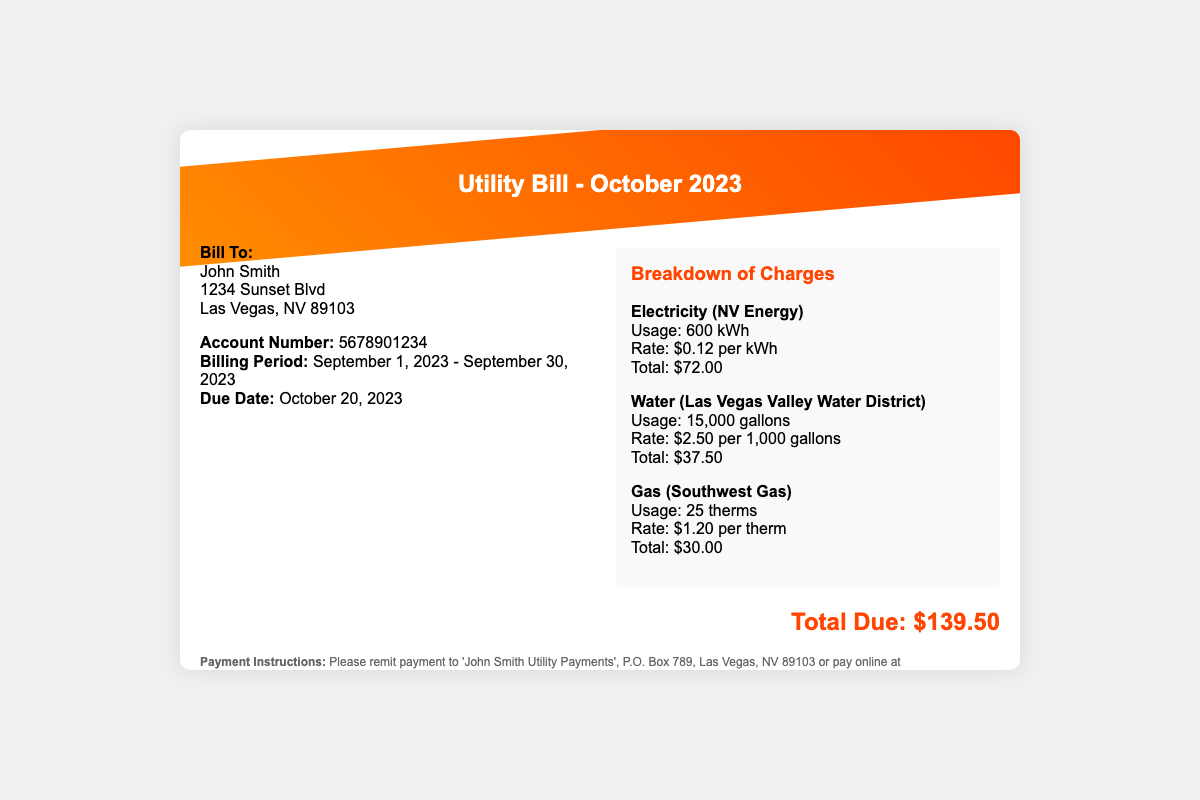what is the due date for the bill? The due date is clearly stated in the document as October 20, 2023.
Answer: October 20, 2023 who is the bill addressed to? The document specifies that the bill is addressed to John Smith.
Answer: John Smith how many gallons of water were used? The document details a water usage of 15,000 gallons.
Answer: 15,000 gallons what is the total amount due? The total amount due is summarized at the end of the document as $139.50.
Answer: $139.50 what is the rate for electricity per kWh? The rate for electricity is mentioned as $0.12 per kWh in the breakdown.
Answer: $0.12 per kWh how many therms of gas were used? The breakdown indicates that 25 therms of gas were used for the billing period.
Answer: 25 therms what is the billing period? The billing period is specified as September 1, 2023 - September 30, 2023.
Answer: September 1, 2023 - September 30, 2023 which utility company provided the gas service? The document states that the gas service is provided by Southwest Gas.
Answer: Southwest Gas what are the payment instructions? The document provides payment instructions for remitting payment to John Smith Utility Payments.
Answer: John Smith Utility Payments 